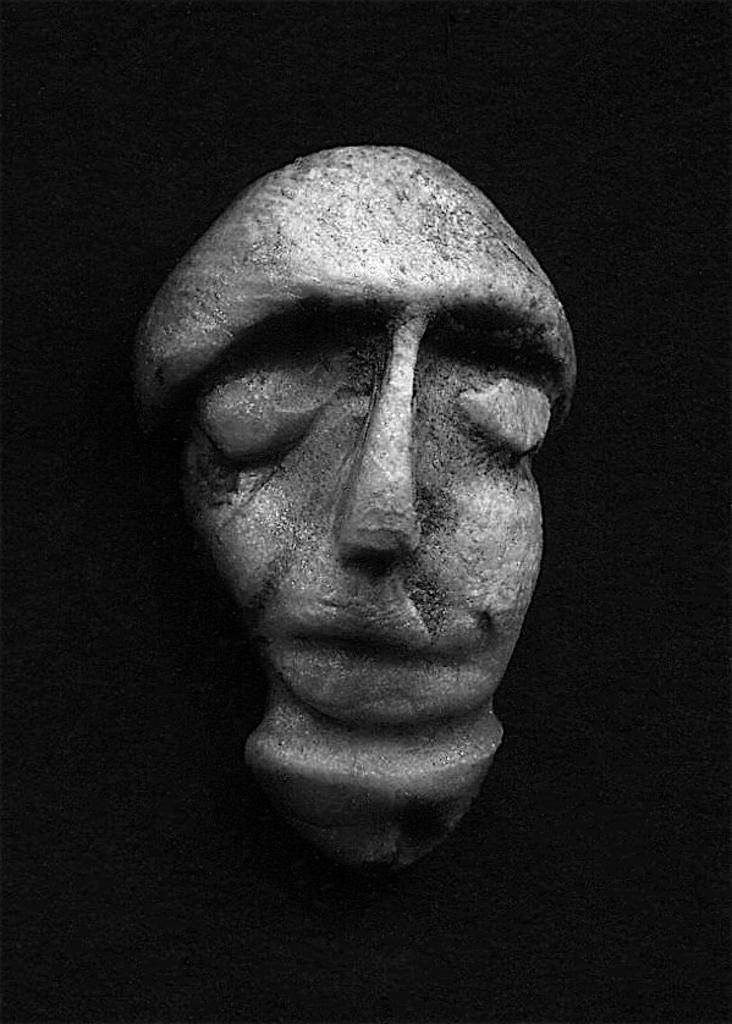What is the main subject in the center of the image? There is a sculpture in the center of the image. What color is the background of the image? The background of the image is black. What type of wine is being served on the mountain in the image? There is no wine or mountain present in the image; it features a sculpture with a black background. 